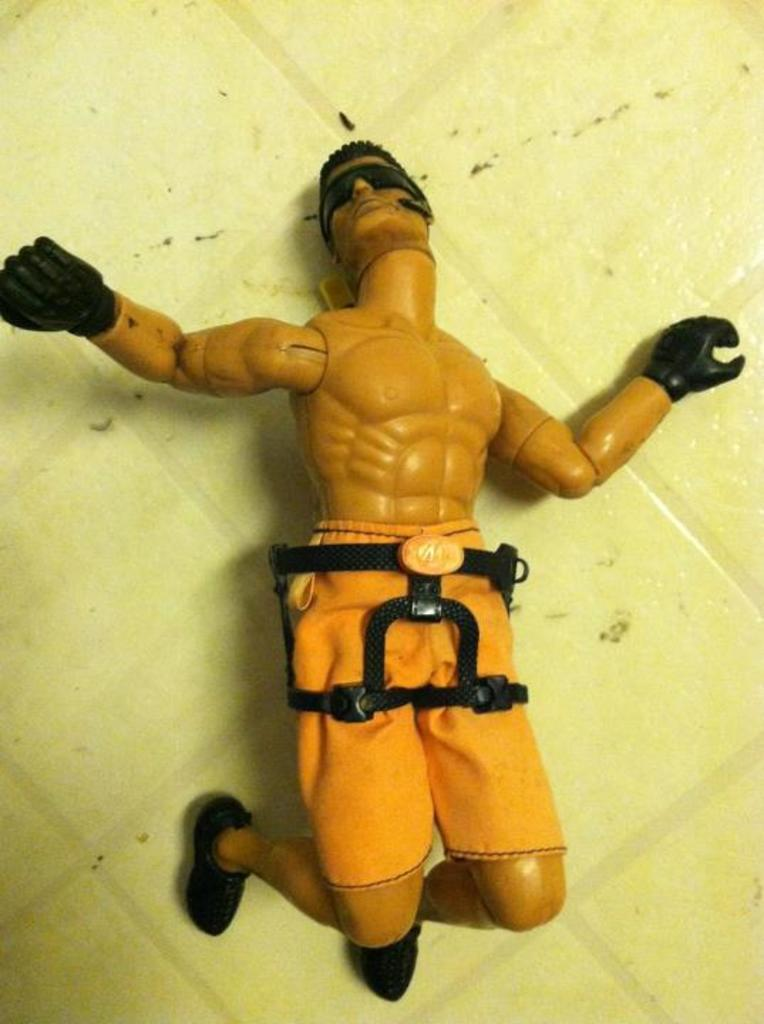What is the main object in the image? There is a toy in the image. What does the toy resemble? The toy resembles a man. Can you describe the toy's appearance? The toy has short hair, gloves, a headband, and shoes. What is the toy standing on in the image? The image shows the floor. How many tomatoes are on the stove in the image? There are no tomatoes or stove present in the image. What is the toy's reaction to the surprise in the image? There is no surprise or reaction in the image; it only shows the toy standing on the floor. 